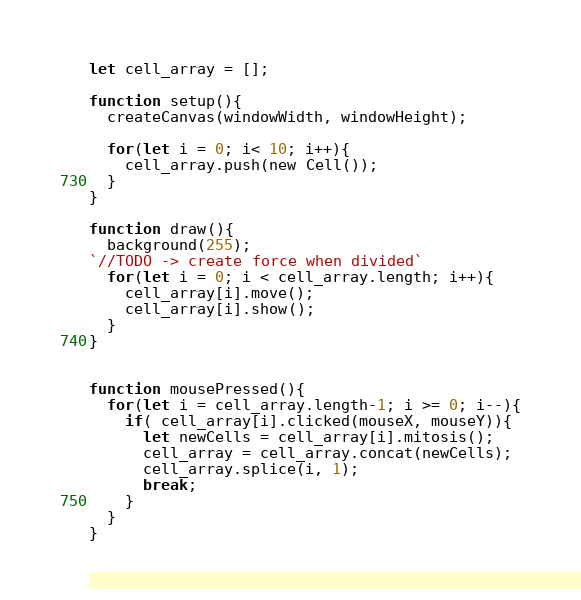<code> <loc_0><loc_0><loc_500><loc_500><_JavaScript_>let cell_array = [];

function setup(){
  createCanvas(windowWidth, windowHeight);

  for(let i = 0; i< 10; i++){
    cell_array.push(new Cell());
  }
}

function draw(){
  background(255);
`//TODO -> create force when divided`
  for(let i = 0; i < cell_array.length; i++){
    cell_array[i].move();
    cell_array[i].show();
  }
}


function mousePressed(){
  for(let i = cell_array.length-1; i >= 0; i--){
    if( cell_array[i].clicked(mouseX, mouseY)){
      let newCells = cell_array[i].mitosis();
      cell_array = cell_array.concat(newCells);
      cell_array.splice(i, 1);
      break;
    }
  }
}
</code> 